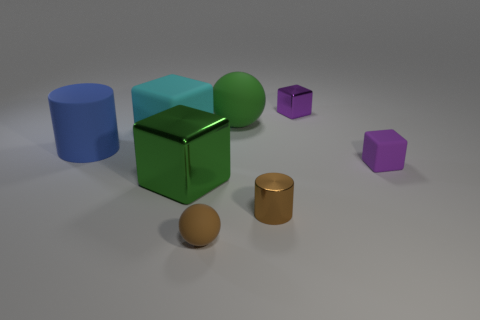Add 2 green cubes. How many objects exist? 10 Subtract all cylinders. How many objects are left? 6 Add 4 blue spheres. How many blue spheres exist? 4 Subtract 0 cyan cylinders. How many objects are left? 8 Subtract all yellow rubber spheres. Subtract all big blue cylinders. How many objects are left? 7 Add 2 cylinders. How many cylinders are left? 4 